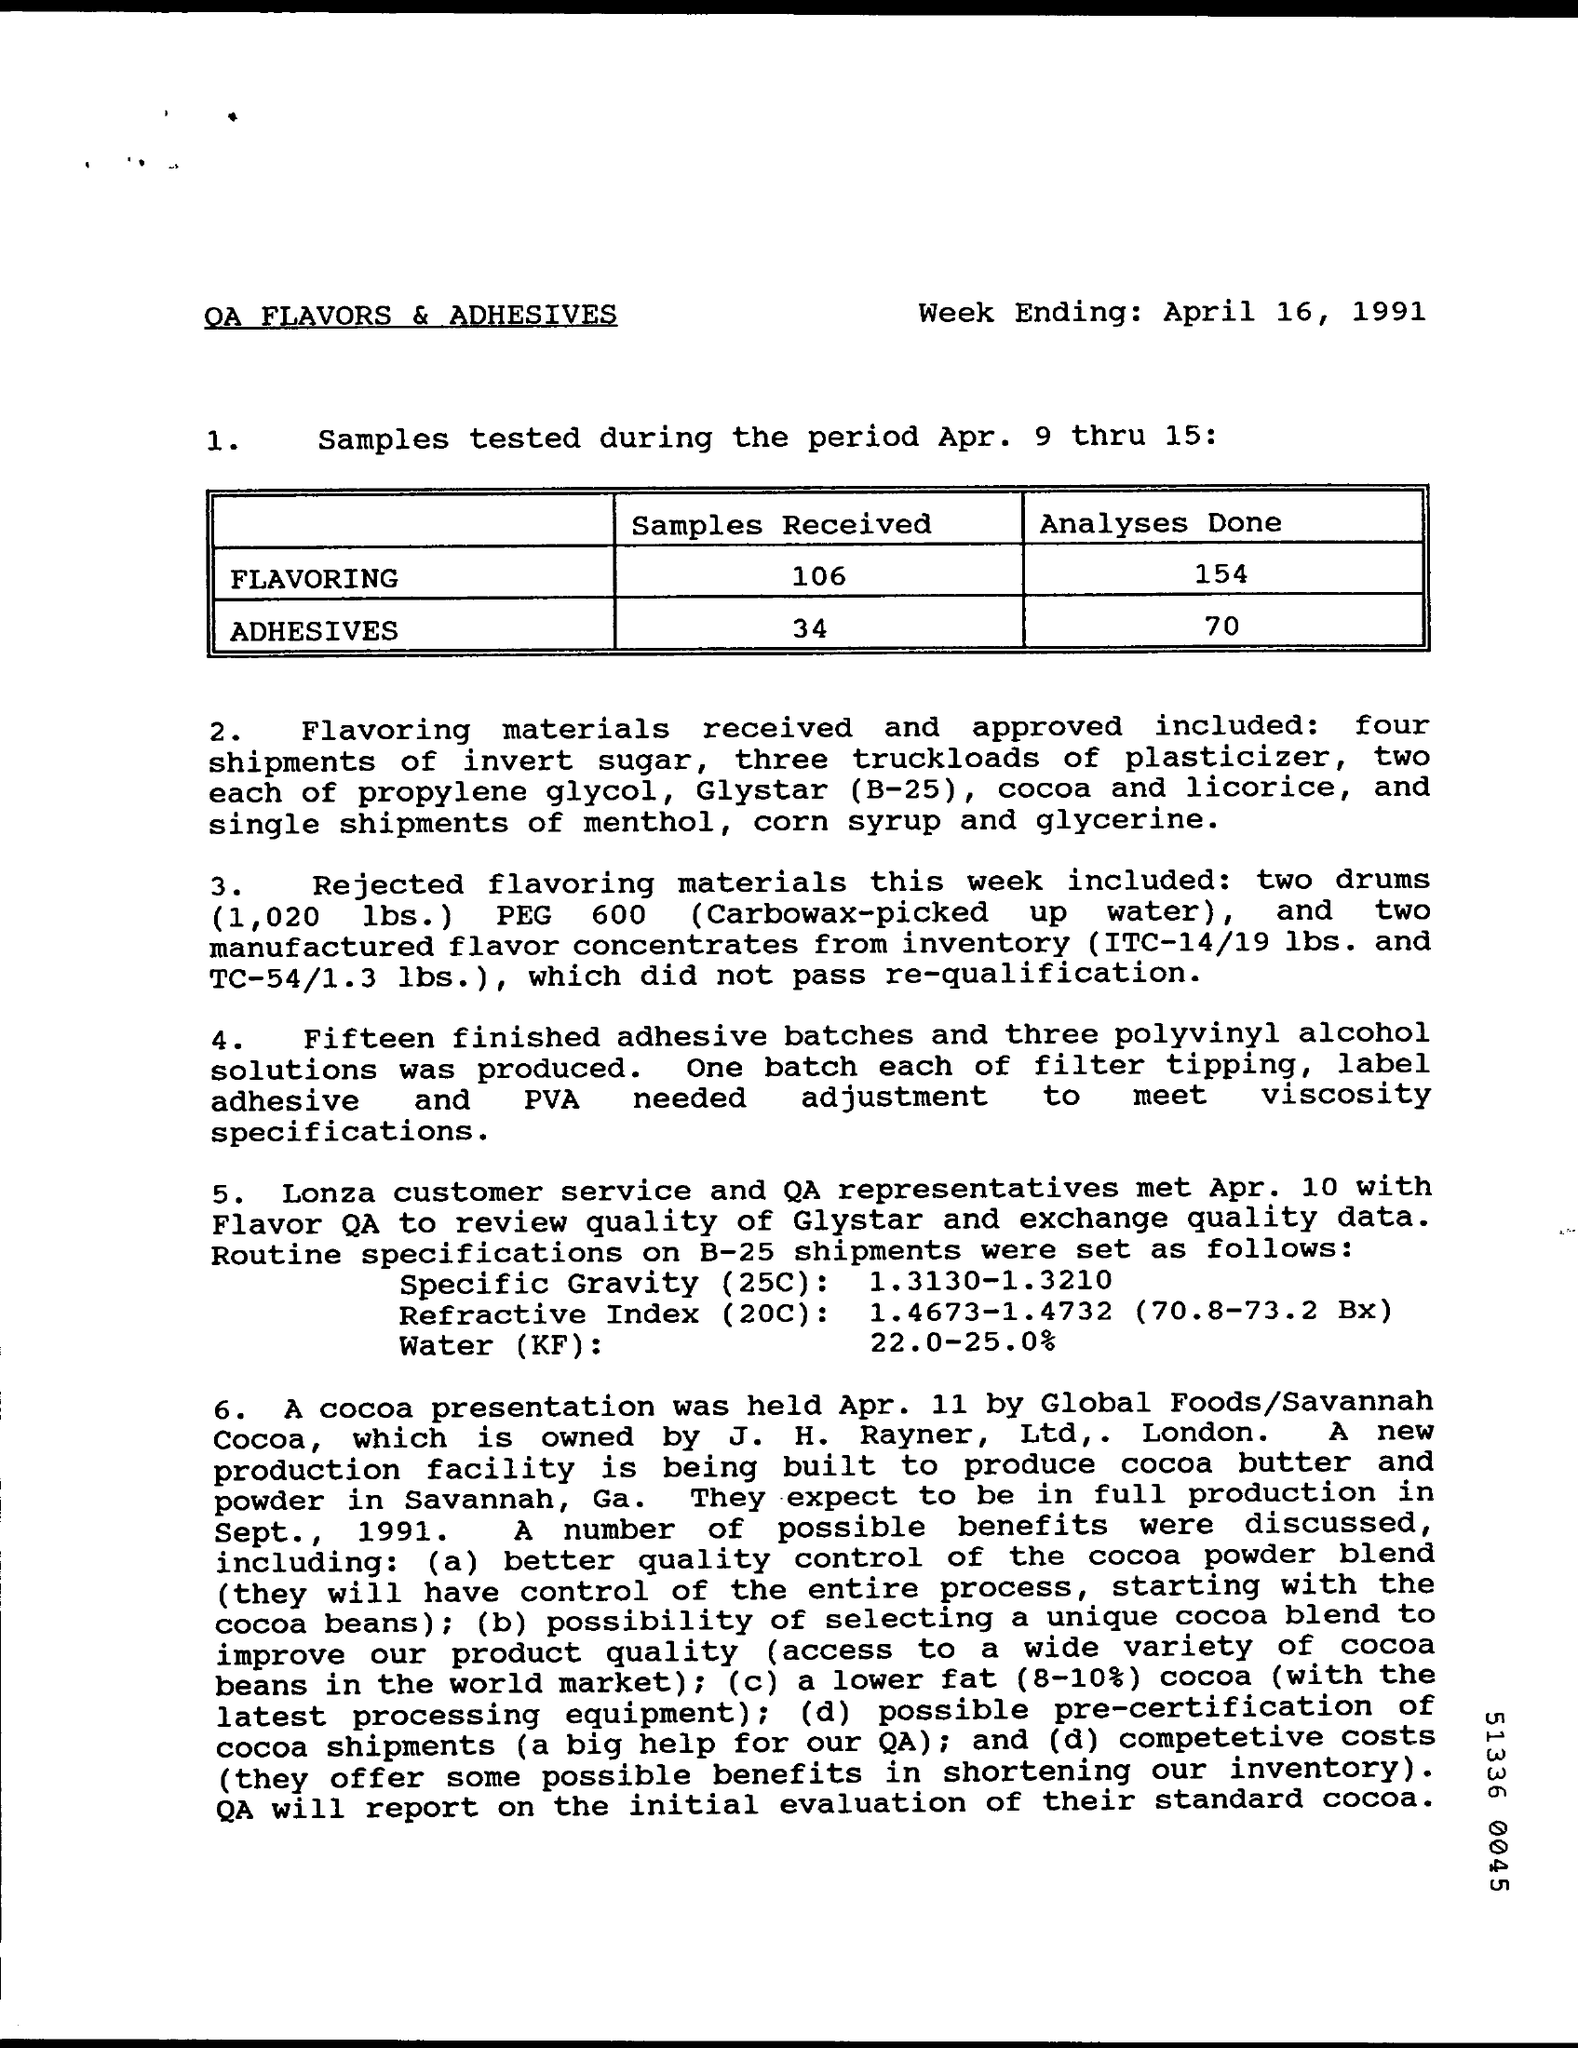When is the week ending?
Offer a terse response. April 16, 1991. How many samples were received for FLAVORING?
Give a very brief answer. 106. When was cocoa presentation held?
Make the answer very short. Apr. 11. 